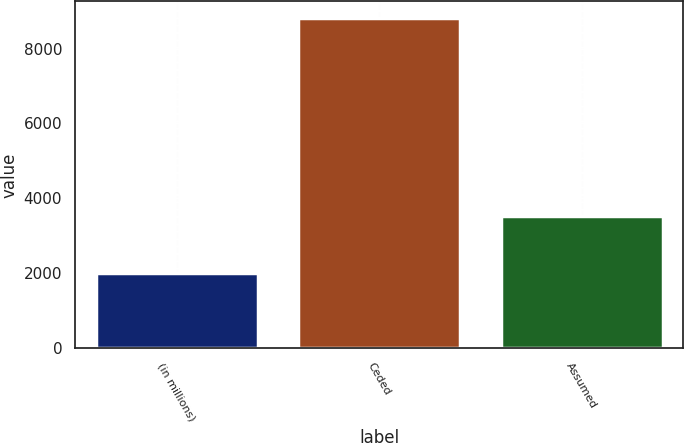Convert chart to OTSL. <chart><loc_0><loc_0><loc_500><loc_500><bar_chart><fcel>(in millions)<fcel>Ceded<fcel>Assumed<nl><fcel>2013<fcel>8816<fcel>3521<nl></chart> 